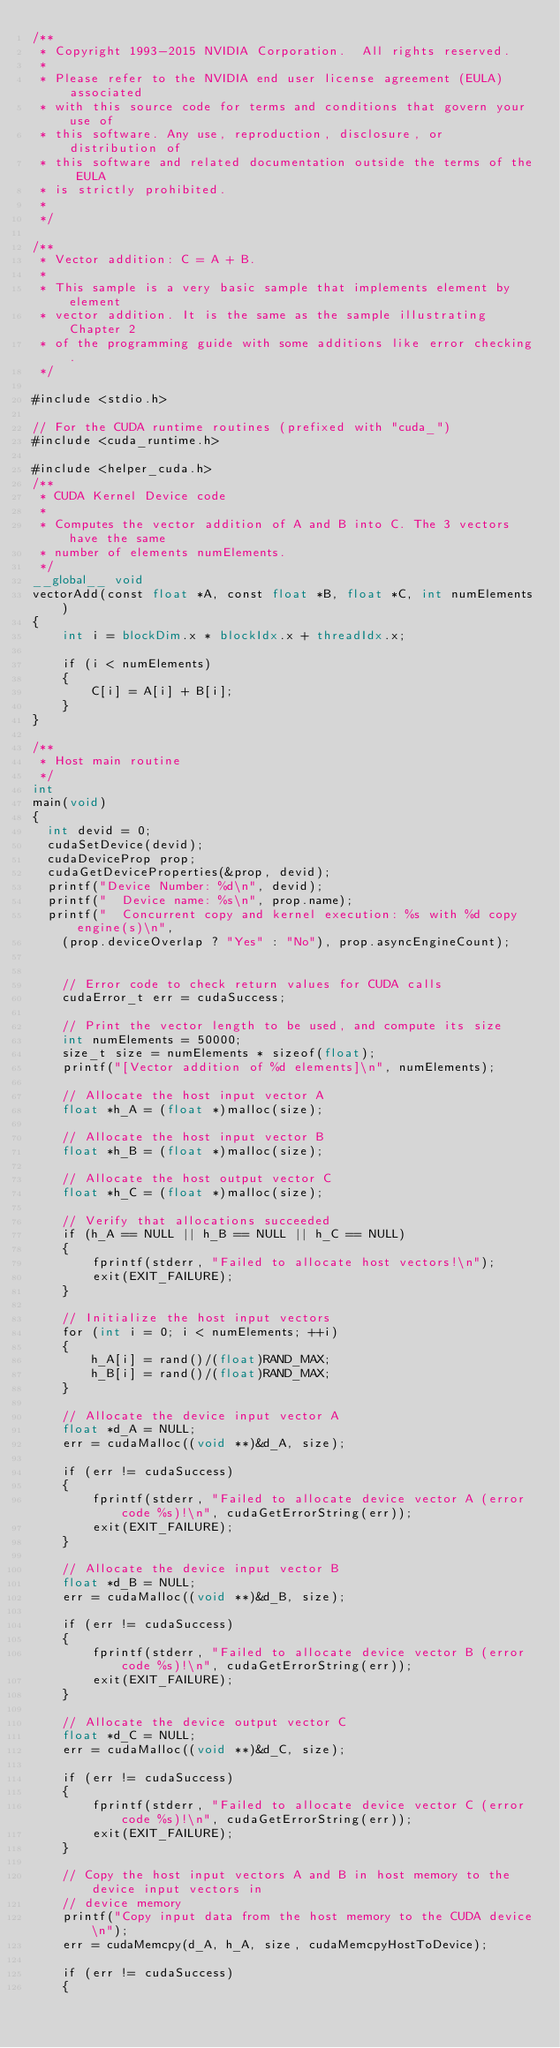<code> <loc_0><loc_0><loc_500><loc_500><_Cuda_>/**
 * Copyright 1993-2015 NVIDIA Corporation.  All rights reserved.
 *
 * Please refer to the NVIDIA end user license agreement (EULA) associated
 * with this source code for terms and conditions that govern your use of
 * this software. Any use, reproduction, disclosure, or distribution of
 * this software and related documentation outside the terms of the EULA
 * is strictly prohibited.
 *
 */

/**
 * Vector addition: C = A + B.
 *
 * This sample is a very basic sample that implements element by element
 * vector addition. It is the same as the sample illustrating Chapter 2
 * of the programming guide with some additions like error checking.
 */

#include <stdio.h>

// For the CUDA runtime routines (prefixed with "cuda_")
#include <cuda_runtime.h>

#include <helper_cuda.h>
/**
 * CUDA Kernel Device code
 *
 * Computes the vector addition of A and B into C. The 3 vectors have the same
 * number of elements numElements.
 */
__global__ void
vectorAdd(const float *A, const float *B, float *C, int numElements)
{
    int i = blockDim.x * blockIdx.x + threadIdx.x;

    if (i < numElements)
    {
        C[i] = A[i] + B[i];
    }
}

/**
 * Host main routine
 */
int
main(void)
{
	int devid = 0;
	cudaSetDevice(devid);
	cudaDeviceProp prop;
	cudaGetDeviceProperties(&prop, devid);
	printf("Device Number: %d\n", devid);
	printf("  Device name: %s\n", prop.name);
	printf("  Concurrent copy and kernel execution: %s with %d copy engine(s)\n", 
   	(prop.deviceOverlap ? "Yes" : "No"), prop.asyncEngineCount);
	

    // Error code to check return values for CUDA calls
    cudaError_t err = cudaSuccess;

    // Print the vector length to be used, and compute its size
    int numElements = 50000;
    size_t size = numElements * sizeof(float);
    printf("[Vector addition of %d elements]\n", numElements);

    // Allocate the host input vector A
    float *h_A = (float *)malloc(size);

    // Allocate the host input vector B
    float *h_B = (float *)malloc(size);

    // Allocate the host output vector C
    float *h_C = (float *)malloc(size);

    // Verify that allocations succeeded
    if (h_A == NULL || h_B == NULL || h_C == NULL)
    {
        fprintf(stderr, "Failed to allocate host vectors!\n");
        exit(EXIT_FAILURE);
    }

    // Initialize the host input vectors
    for (int i = 0; i < numElements; ++i)
    {
        h_A[i] = rand()/(float)RAND_MAX;
        h_B[i] = rand()/(float)RAND_MAX;
    }

    // Allocate the device input vector A
    float *d_A = NULL;
    err = cudaMalloc((void **)&d_A, size);

    if (err != cudaSuccess)
    {
        fprintf(stderr, "Failed to allocate device vector A (error code %s)!\n", cudaGetErrorString(err));
        exit(EXIT_FAILURE);
    }

    // Allocate the device input vector B
    float *d_B = NULL;
    err = cudaMalloc((void **)&d_B, size);

    if (err != cudaSuccess)
    {
        fprintf(stderr, "Failed to allocate device vector B (error code %s)!\n", cudaGetErrorString(err));
        exit(EXIT_FAILURE);
    }

    // Allocate the device output vector C
    float *d_C = NULL;
    err = cudaMalloc((void **)&d_C, size);

    if (err != cudaSuccess)
    {
        fprintf(stderr, "Failed to allocate device vector C (error code %s)!\n", cudaGetErrorString(err));
        exit(EXIT_FAILURE);
    }

    // Copy the host input vectors A and B in host memory to the device input vectors in
    // device memory
    printf("Copy input data from the host memory to the CUDA device\n");
    err = cudaMemcpy(d_A, h_A, size, cudaMemcpyHostToDevice);

    if (err != cudaSuccess)
    {</code> 